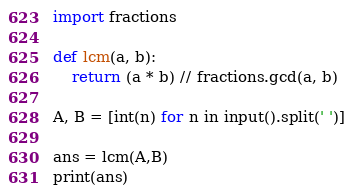Convert code to text. <code><loc_0><loc_0><loc_500><loc_500><_Python_>import fractions

def lcm(a, b):
    return (a * b) // fractions.gcd(a, b)

A, B = [int(n) for n in input().split(' ')]

ans = lcm(A,B)
print(ans)
</code> 